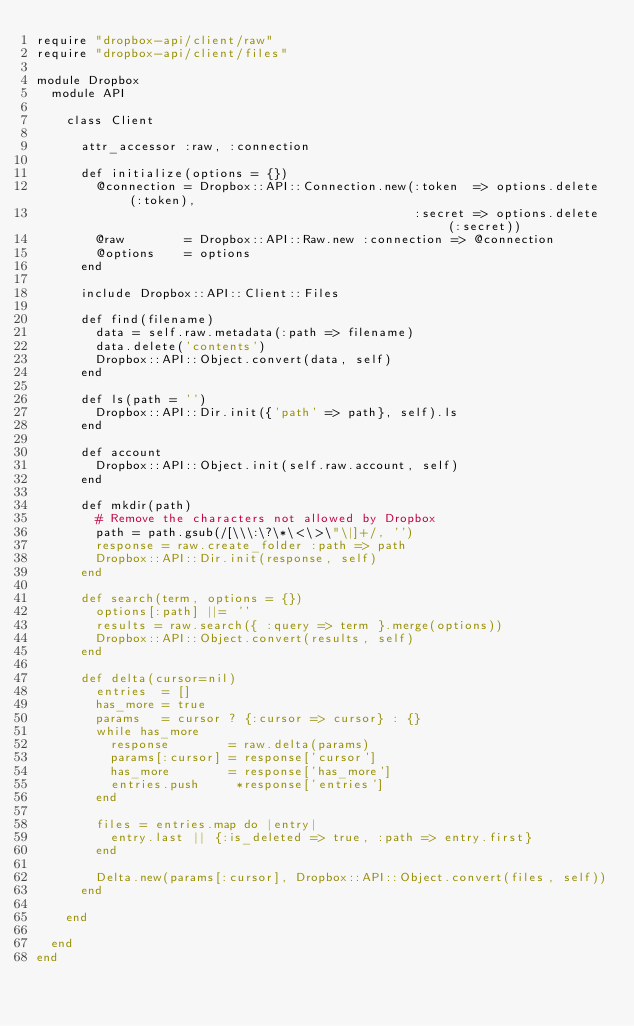<code> <loc_0><loc_0><loc_500><loc_500><_Ruby_>require "dropbox-api/client/raw"
require "dropbox-api/client/files"

module Dropbox
  module API

    class Client

      attr_accessor :raw, :connection

      def initialize(options = {})
        @connection = Dropbox::API::Connection.new(:token  => options.delete(:token),
                                                   :secret => options.delete(:secret))
        @raw        = Dropbox::API::Raw.new :connection => @connection
        @options    = options
      end

      include Dropbox::API::Client::Files

      def find(filename)
        data = self.raw.metadata(:path => filename)
        data.delete('contents')
        Dropbox::API::Object.convert(data, self)
      end

      def ls(path = '')
        Dropbox::API::Dir.init({'path' => path}, self).ls
      end

      def account
        Dropbox::API::Object.init(self.raw.account, self)
      end

      def mkdir(path)
        # Remove the characters not allowed by Dropbox
        path = path.gsub(/[\\\:\?\*\<\>\"\|]+/, '')
        response = raw.create_folder :path => path
        Dropbox::API::Dir.init(response, self)
      end

      def search(term, options = {})
        options[:path] ||= ''
        results = raw.search({ :query => term }.merge(options))
        Dropbox::API::Object.convert(results, self)
      end

      def delta(cursor=nil)
        entries  = []
        has_more = true
        params   = cursor ? {:cursor => cursor} : {}
        while has_more
          response        = raw.delta(params)
          params[:cursor] = response['cursor']
          has_more        = response['has_more']
          entries.push     *response['entries']
        end

        files = entries.map do |entry|
          entry.last || {:is_deleted => true, :path => entry.first}
        end

        Delta.new(params[:cursor], Dropbox::API::Object.convert(files, self))
      end

    end

  end
end
</code> 